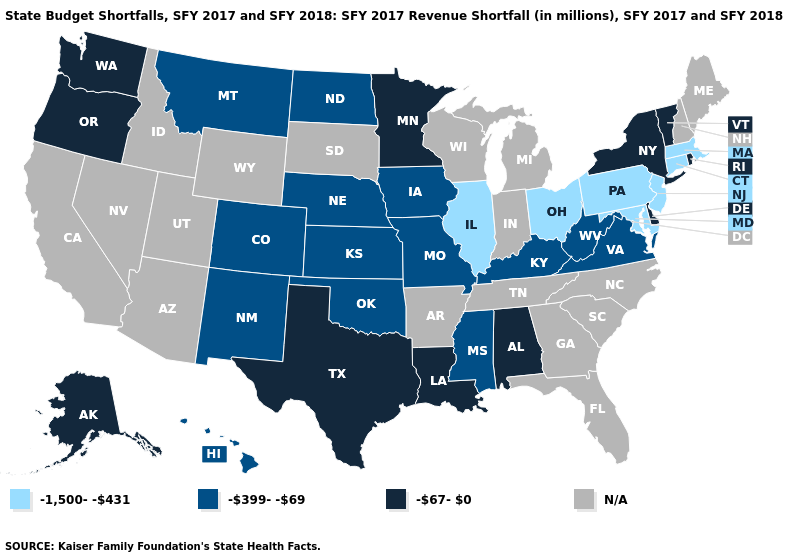What is the lowest value in states that border Rhode Island?
Write a very short answer. -1,500--431. Does Maryland have the lowest value in the South?
Be succinct. Yes. Does the first symbol in the legend represent the smallest category?
Answer briefly. Yes. Among the states that border Nebraska , which have the lowest value?
Give a very brief answer. Colorado, Iowa, Kansas, Missouri. Does the map have missing data?
Write a very short answer. Yes. Is the legend a continuous bar?
Give a very brief answer. No. What is the highest value in the South ?
Short answer required. -67-0. Is the legend a continuous bar?
Be succinct. No. Name the states that have a value in the range N/A?
Quick response, please. Arizona, Arkansas, California, Florida, Georgia, Idaho, Indiana, Maine, Michigan, Nevada, New Hampshire, North Carolina, South Carolina, South Dakota, Tennessee, Utah, Wisconsin, Wyoming. Name the states that have a value in the range -67-0?
Short answer required. Alabama, Alaska, Delaware, Louisiana, Minnesota, New York, Oregon, Rhode Island, Texas, Vermont, Washington. What is the value of New Jersey?
Give a very brief answer. -1,500--431. What is the value of Iowa?
Keep it brief. -399--69. Name the states that have a value in the range -67-0?
Be succinct. Alabama, Alaska, Delaware, Louisiana, Minnesota, New York, Oregon, Rhode Island, Texas, Vermont, Washington. Which states have the highest value in the USA?
Give a very brief answer. Alabama, Alaska, Delaware, Louisiana, Minnesota, New York, Oregon, Rhode Island, Texas, Vermont, Washington. 